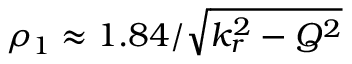Convert formula to latex. <formula><loc_0><loc_0><loc_500><loc_500>\rho _ { 1 } \approx 1 . 8 4 / \sqrt { k _ { r } ^ { 2 } - Q ^ { 2 } }</formula> 